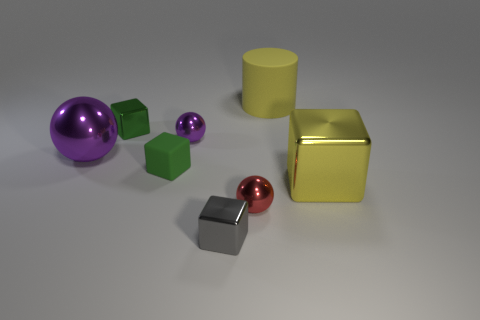There is a tiny shiny object that is the same color as the small rubber thing; what shape is it?
Your response must be concise. Cube. Do the tiny cube in front of the big yellow metal cube and the tiny ball that is to the right of the gray object have the same material?
Your response must be concise. Yes. What number of red objects have the same shape as the tiny green metallic thing?
Give a very brief answer. 0. What number of cylinders have the same color as the rubber block?
Offer a terse response. 0. There is a big shiny object on the left side of the yellow metallic object; does it have the same shape as the purple metal object behind the big purple object?
Provide a short and direct response. Yes. What number of purple shiny balls are in front of the green cube behind the metallic sphere to the left of the tiny green matte object?
Give a very brief answer. 2. What material is the tiny block that is behind the purple shiny ball that is on the left side of the tiny metal block behind the big purple sphere?
Your response must be concise. Metal. Are the tiny ball left of the tiny gray block and the cylinder made of the same material?
Ensure brevity in your answer.  No. How many purple things have the same size as the yellow metallic thing?
Ensure brevity in your answer.  1. Are there more small metallic cubes in front of the small purple metal sphere than gray metallic blocks that are left of the green rubber cube?
Ensure brevity in your answer.  Yes. 